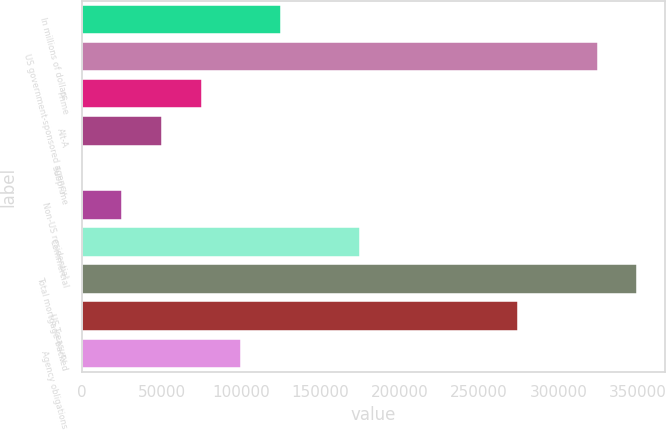<chart> <loc_0><loc_0><loc_500><loc_500><bar_chart><fcel>In millions of dollars<fcel>US government-sponsored agency<fcel>Prime<fcel>Alt-A<fcel>Subprime<fcel>Non-US residential<fcel>Commercial<fcel>Total mortgage-backed<fcel>US Treasury<fcel>Agency obligations<nl><fcel>125236<fcel>324788<fcel>75348<fcel>50404<fcel>516<fcel>25460<fcel>175124<fcel>349732<fcel>274900<fcel>100292<nl></chart> 